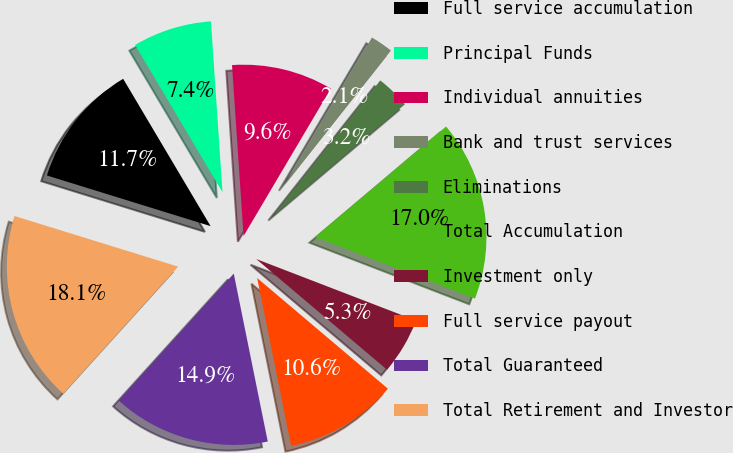<chart> <loc_0><loc_0><loc_500><loc_500><pie_chart><fcel>Full service accumulation<fcel>Principal Funds<fcel>Individual annuities<fcel>Bank and trust services<fcel>Eliminations<fcel>Total Accumulation<fcel>Investment only<fcel>Full service payout<fcel>Total Guaranteed<fcel>Total Retirement and Investor<nl><fcel>11.7%<fcel>7.45%<fcel>9.58%<fcel>2.14%<fcel>3.2%<fcel>17.01%<fcel>5.33%<fcel>10.64%<fcel>14.89%<fcel>18.07%<nl></chart> 